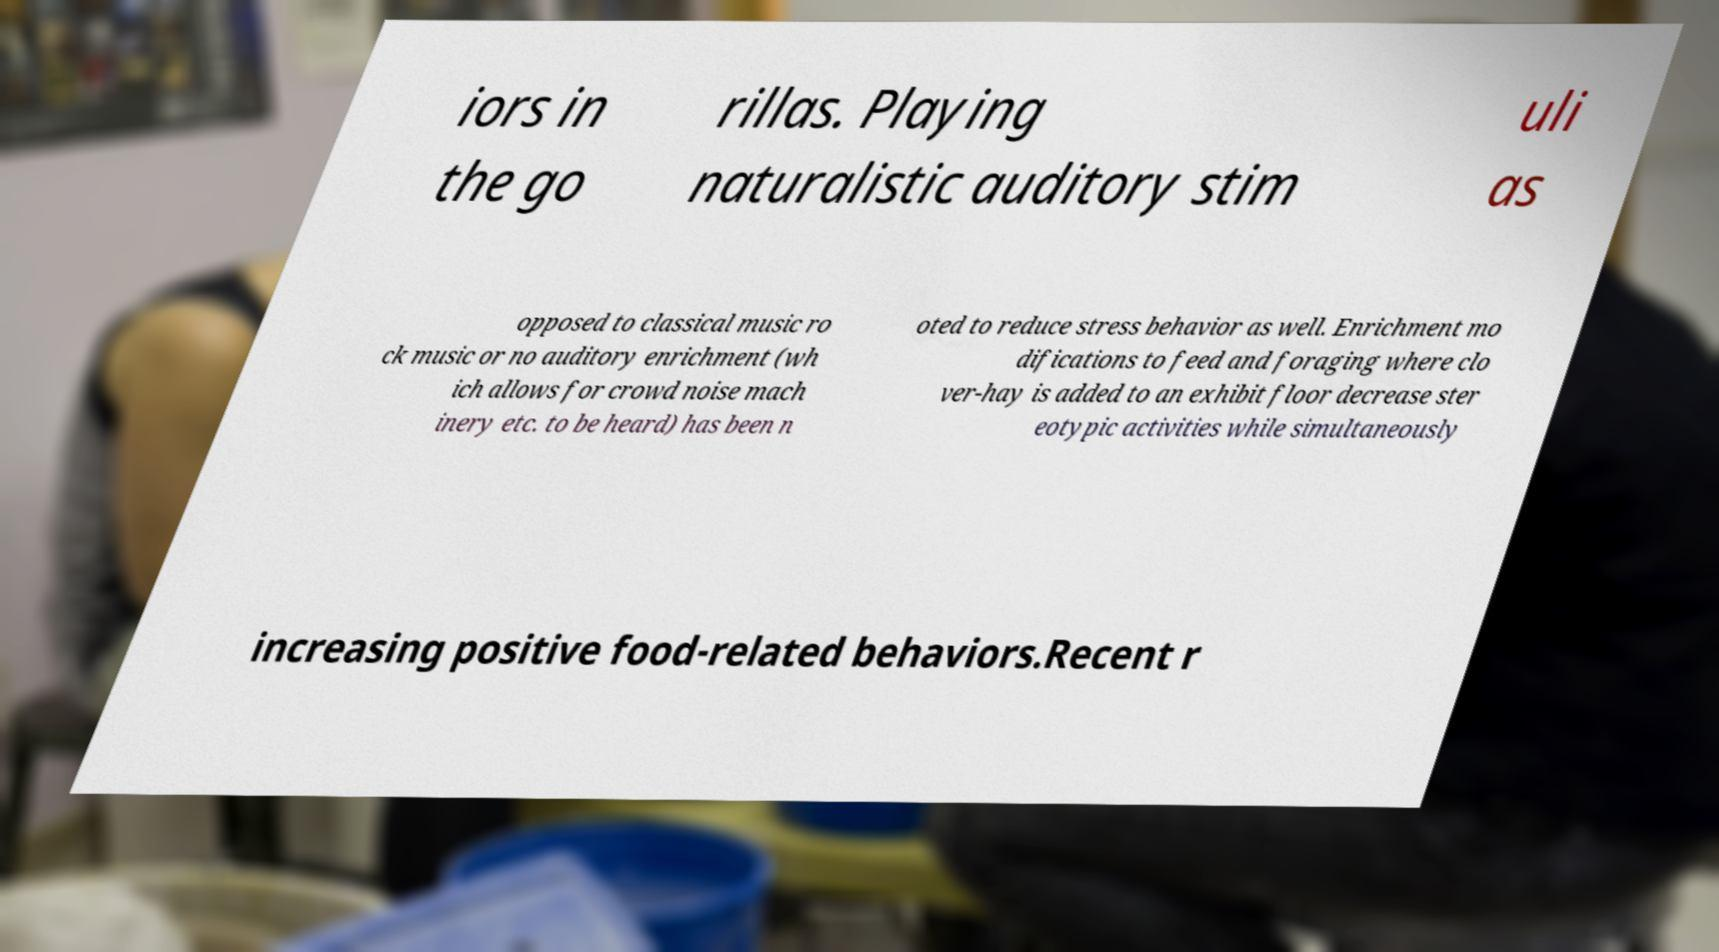Could you assist in decoding the text presented in this image and type it out clearly? iors in the go rillas. Playing naturalistic auditory stim uli as opposed to classical music ro ck music or no auditory enrichment (wh ich allows for crowd noise mach inery etc. to be heard) has been n oted to reduce stress behavior as well. Enrichment mo difications to feed and foraging where clo ver-hay is added to an exhibit floor decrease ster eotypic activities while simultaneously increasing positive food-related behaviors.Recent r 